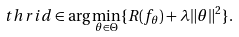<formula> <loc_0><loc_0><loc_500><loc_500>\ t h r i d \in \arg \min _ { \theta \in \Theta } \{ R ( f _ { \theta } ) + \lambda \| \theta \| ^ { 2 } \} .</formula> 